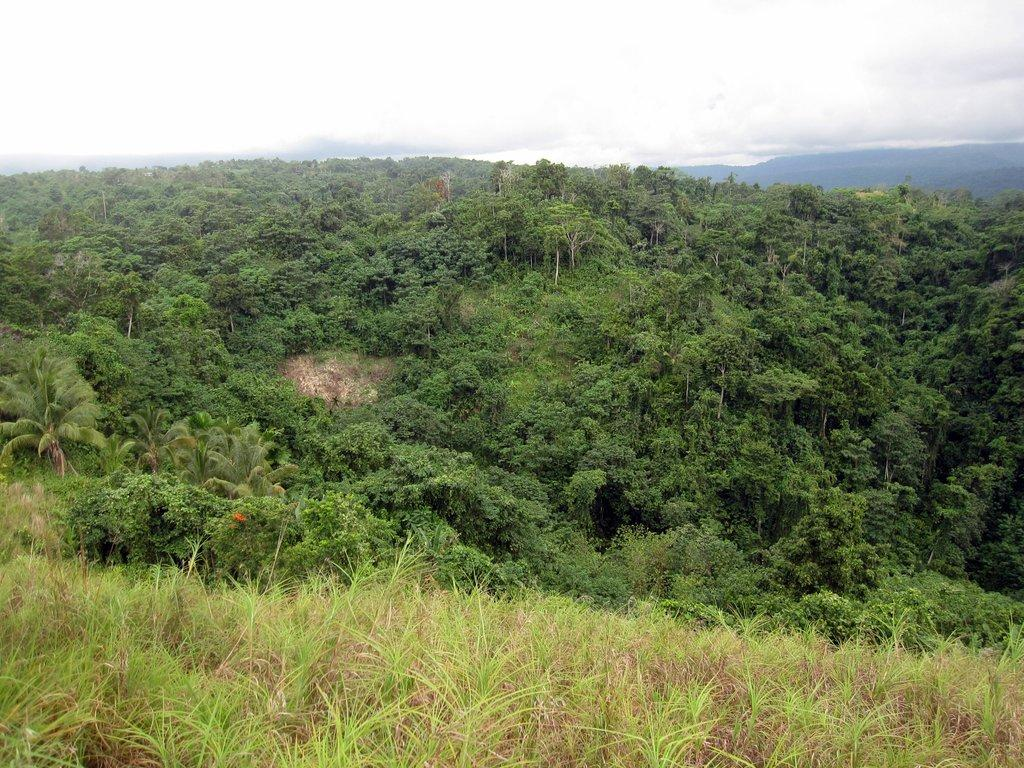What type of vegetation is at the bottom of the image? There is grass at the bottom of the image. What can be seen in the background of the image? There are trees and a hill in the background of the image. What is visible in the sky in the image? The sky is visible in the background of the image. What type of wing is visible in the image? There is no wing present in the image. What type of soda can be seen in the image? There is no soda present in the image. 